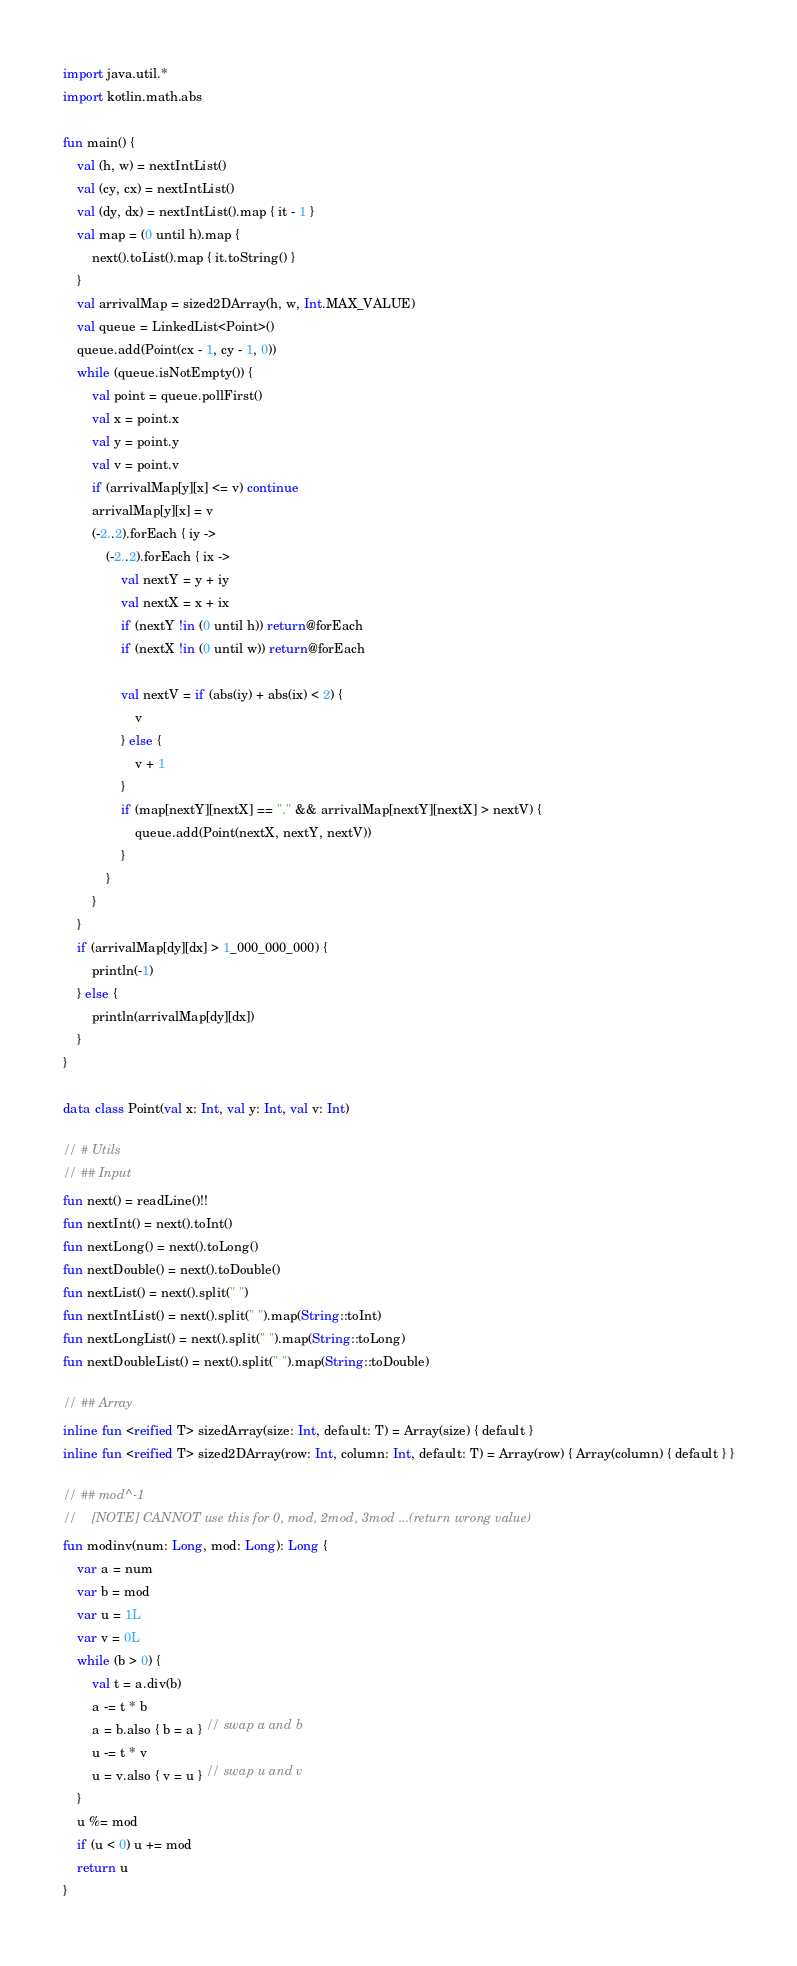Convert code to text. <code><loc_0><loc_0><loc_500><loc_500><_Kotlin_>import java.util.*
import kotlin.math.abs

fun main() {
    val (h, w) = nextIntList()
    val (cy, cx) = nextIntList()
    val (dy, dx) = nextIntList().map { it - 1 }
    val map = (0 until h).map {
        next().toList().map { it.toString() }
    }
    val arrivalMap = sized2DArray(h, w, Int.MAX_VALUE)
    val queue = LinkedList<Point>()
    queue.add(Point(cx - 1, cy - 1, 0))
    while (queue.isNotEmpty()) {
        val point = queue.pollFirst()
        val x = point.x
        val y = point.y
        val v = point.v
        if (arrivalMap[y][x] <= v) continue
        arrivalMap[y][x] = v
        (-2..2).forEach { iy ->
            (-2..2).forEach { ix ->
                val nextY = y + iy
                val nextX = x + ix
                if (nextY !in (0 until h)) return@forEach
                if (nextX !in (0 until w)) return@forEach

                val nextV = if (abs(iy) + abs(ix) < 2) {
                    v
                } else {
                    v + 1
                }
                if (map[nextY][nextX] == "." && arrivalMap[nextY][nextX] > nextV) {
                    queue.add(Point(nextX, nextY, nextV))
                }
            }
        }
    }
    if (arrivalMap[dy][dx] > 1_000_000_000) {
        println(-1)
    } else {
        println(arrivalMap[dy][dx])
    }
}

data class Point(val x: Int, val y: Int, val v: Int)

// # Utils
// ## Input
fun next() = readLine()!!
fun nextInt() = next().toInt()
fun nextLong() = next().toLong()
fun nextDouble() = next().toDouble()
fun nextList() = next().split(" ")
fun nextIntList() = next().split(" ").map(String::toInt)
fun nextLongList() = next().split(" ").map(String::toLong)
fun nextDoubleList() = next().split(" ").map(String::toDouble)

// ## Array
inline fun <reified T> sizedArray(size: Int, default: T) = Array(size) { default }
inline fun <reified T> sized2DArray(row: Int, column: Int, default: T) = Array(row) { Array(column) { default } }

// ## mod^-1
//    [NOTE] CANNOT use this for 0, mod, 2mod, 3mod ...(return wrong value)
fun modinv(num: Long, mod: Long): Long {
    var a = num
    var b = mod
    var u = 1L
    var v = 0L
    while (b > 0) {
        val t = a.div(b)
        a -= t * b
        a = b.also { b = a } // swap a and b
        u -= t * v
        u = v.also { v = u } // swap u and v
    }
    u %= mod
    if (u < 0) u += mod
    return u
}</code> 